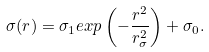Convert formula to latex. <formula><loc_0><loc_0><loc_500><loc_500>\sigma ( r ) = \sigma _ { 1 } e x p \left ( - \frac { r ^ { 2 } } { r _ { \sigma } ^ { 2 } } \right ) + \sigma _ { 0 } .</formula> 